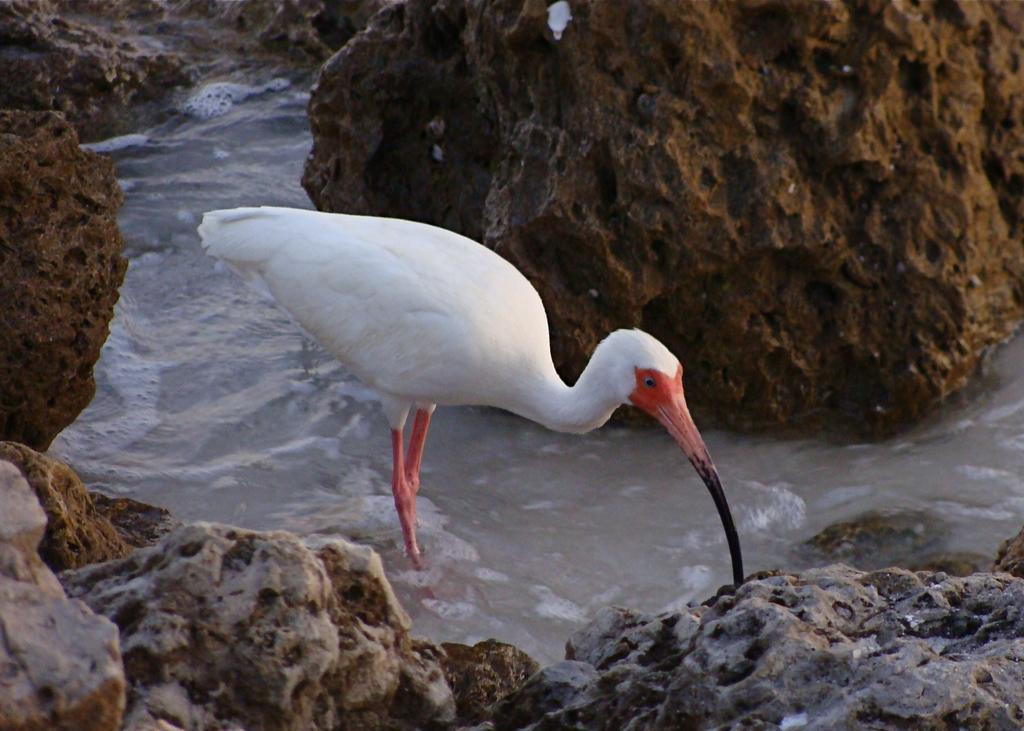What is the main subject of the image? There is a crane in the image. Where is the crane located? The crane is standing in the water. What else can be seen in the image besides the crane? There are rocks in the image. What is happening with the water in the image? Water is flowing in the image. What type of vegetable is being harvested by the government in the image? There is no vegetable or government presence in the image; it features a crane standing in the water with rocks and flowing water. 